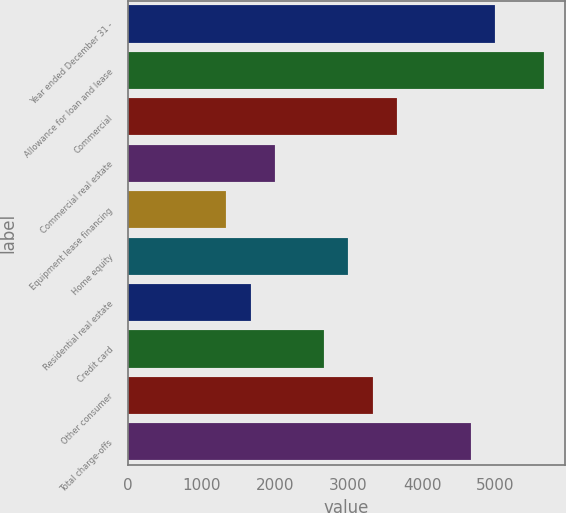Convert chart. <chart><loc_0><loc_0><loc_500><loc_500><bar_chart><fcel>Year ended December 31 -<fcel>Allowance for loan and lease<fcel>Commercial<fcel>Commercial real estate<fcel>Equipment lease financing<fcel>Home equity<fcel>Residential real estate<fcel>Credit card<fcel>Other consumer<fcel>Total charge-offs<nl><fcel>4996.47<fcel>5662.65<fcel>3664.11<fcel>1998.66<fcel>1332.48<fcel>2997.93<fcel>1665.57<fcel>2664.84<fcel>3331.02<fcel>4663.38<nl></chart> 